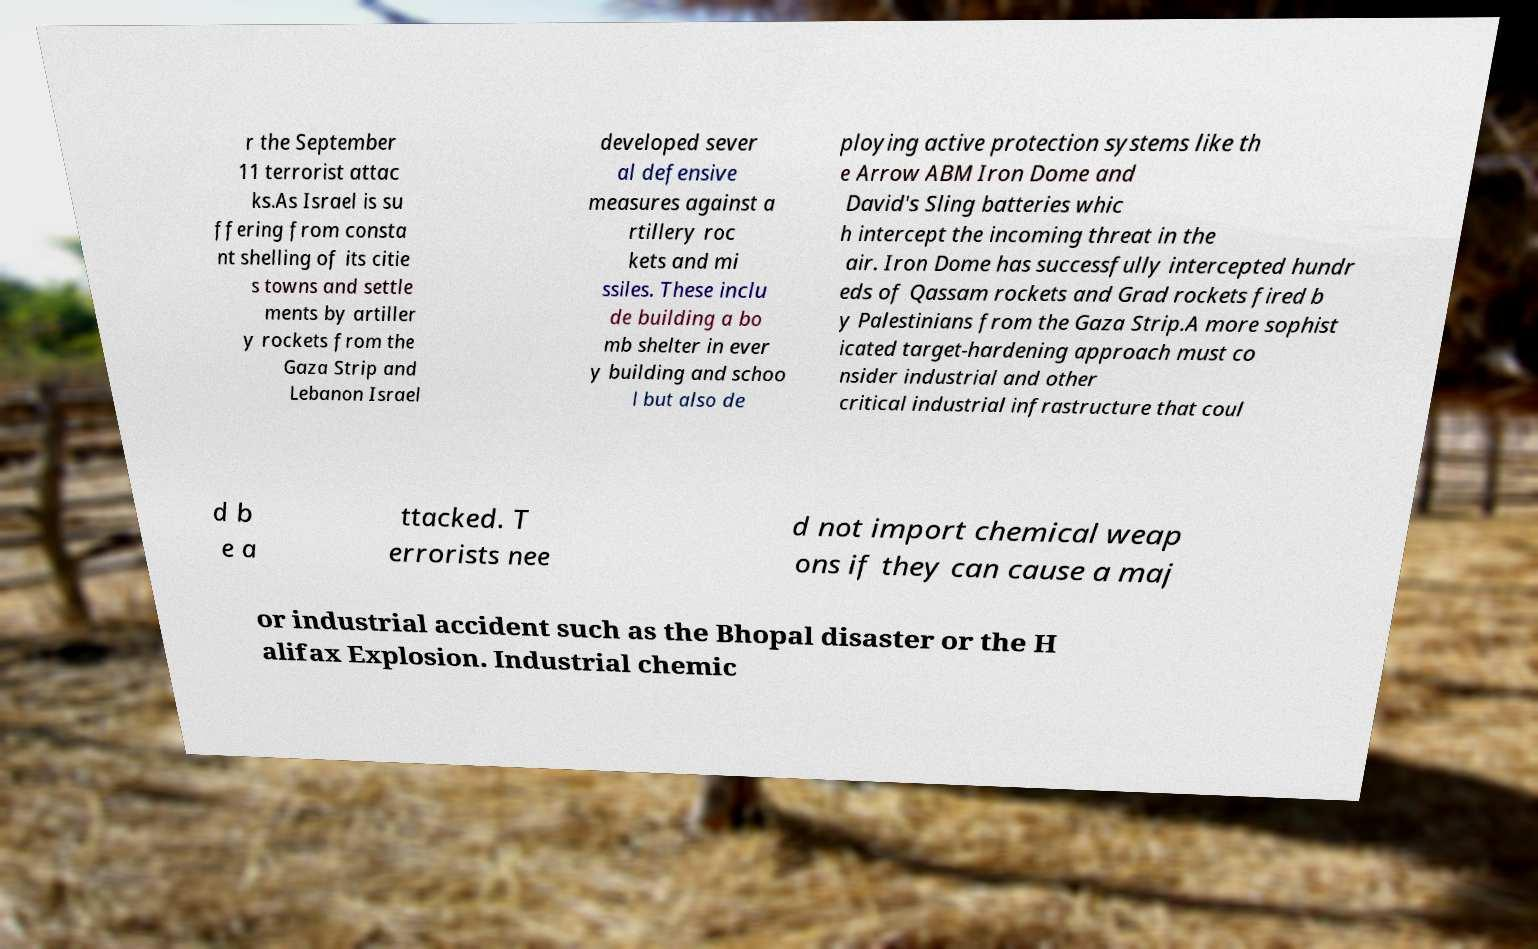Please identify and transcribe the text found in this image. r the September 11 terrorist attac ks.As Israel is su ffering from consta nt shelling of its citie s towns and settle ments by artiller y rockets from the Gaza Strip and Lebanon Israel developed sever al defensive measures against a rtillery roc kets and mi ssiles. These inclu de building a bo mb shelter in ever y building and schoo l but also de ploying active protection systems like th e Arrow ABM Iron Dome and David's Sling batteries whic h intercept the incoming threat in the air. Iron Dome has successfully intercepted hundr eds of Qassam rockets and Grad rockets fired b y Palestinians from the Gaza Strip.A more sophist icated target-hardening approach must co nsider industrial and other critical industrial infrastructure that coul d b e a ttacked. T errorists nee d not import chemical weap ons if they can cause a maj or industrial accident such as the Bhopal disaster or the H alifax Explosion. Industrial chemic 